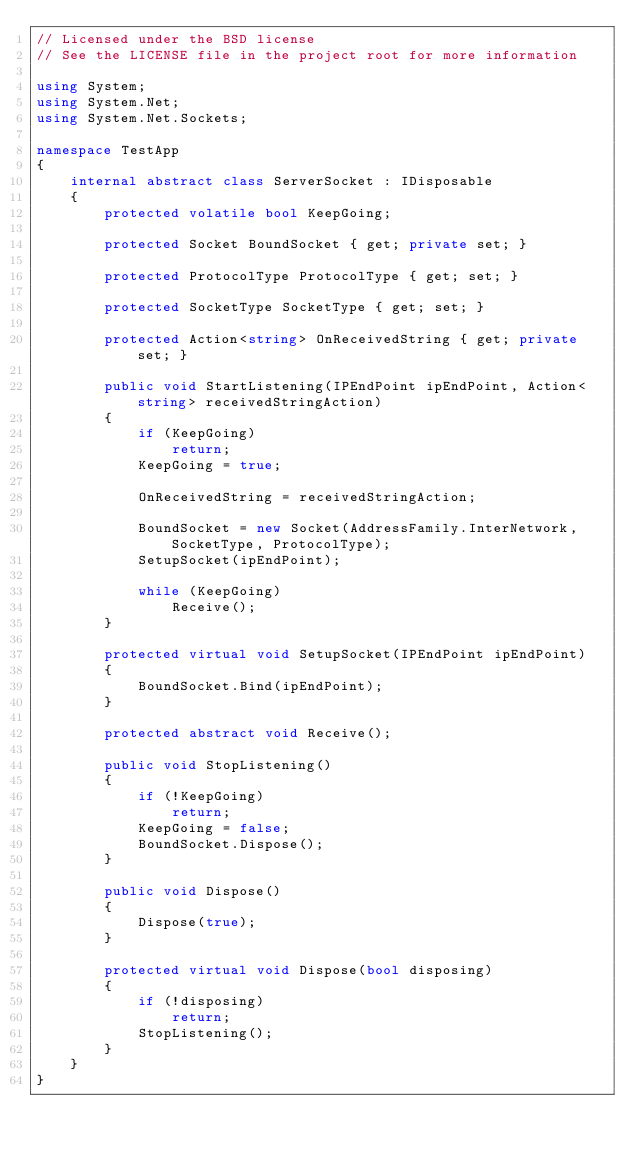Convert code to text. <code><loc_0><loc_0><loc_500><loc_500><_C#_>// Licensed under the BSD license
// See the LICENSE file in the project root for more information

using System;
using System.Net;
using System.Net.Sockets;

namespace TestApp
{
    internal abstract class ServerSocket : IDisposable
    {
        protected volatile bool KeepGoing;

        protected Socket BoundSocket { get; private set; }

        protected ProtocolType ProtocolType { get; set; }

        protected SocketType SocketType { get; set; }

        protected Action<string> OnReceivedString { get; private set; }

        public void StartListening(IPEndPoint ipEndPoint, Action<string> receivedStringAction)
        {
            if (KeepGoing)
                return;
            KeepGoing = true;

            OnReceivedString = receivedStringAction;

            BoundSocket = new Socket(AddressFamily.InterNetwork, SocketType, ProtocolType);
            SetupSocket(ipEndPoint);

            while (KeepGoing)
                Receive();
        }

        protected virtual void SetupSocket(IPEndPoint ipEndPoint)
        {
            BoundSocket.Bind(ipEndPoint);
        }

        protected abstract void Receive();

        public void StopListening()
        {
            if (!KeepGoing)
                return;
            KeepGoing = false;
            BoundSocket.Dispose();
        }

        public void Dispose()
        {
            Dispose(true);
        }

        protected virtual void Dispose(bool disposing)
        {
            if (!disposing)
                return;
            StopListening();
        }
    }
}</code> 